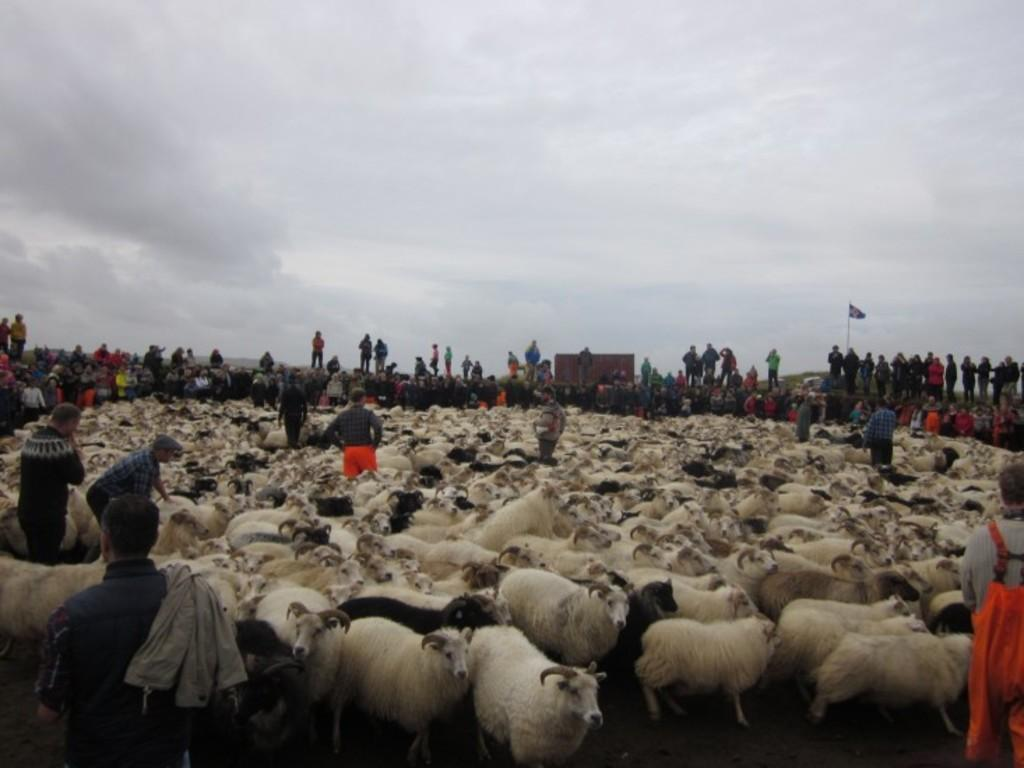Who or what can be seen in the image? There are people and sheep in the image. What is located in the background of the image? There is a flag pole and the sky visible in the background of the image. What can be observed in the sky? Clouds are present in the sky. What type of copper material can be seen in the stomach of the sheep in the image? There is no copper material present in the image, nor is there any indication of a sheep's stomach being visible. 